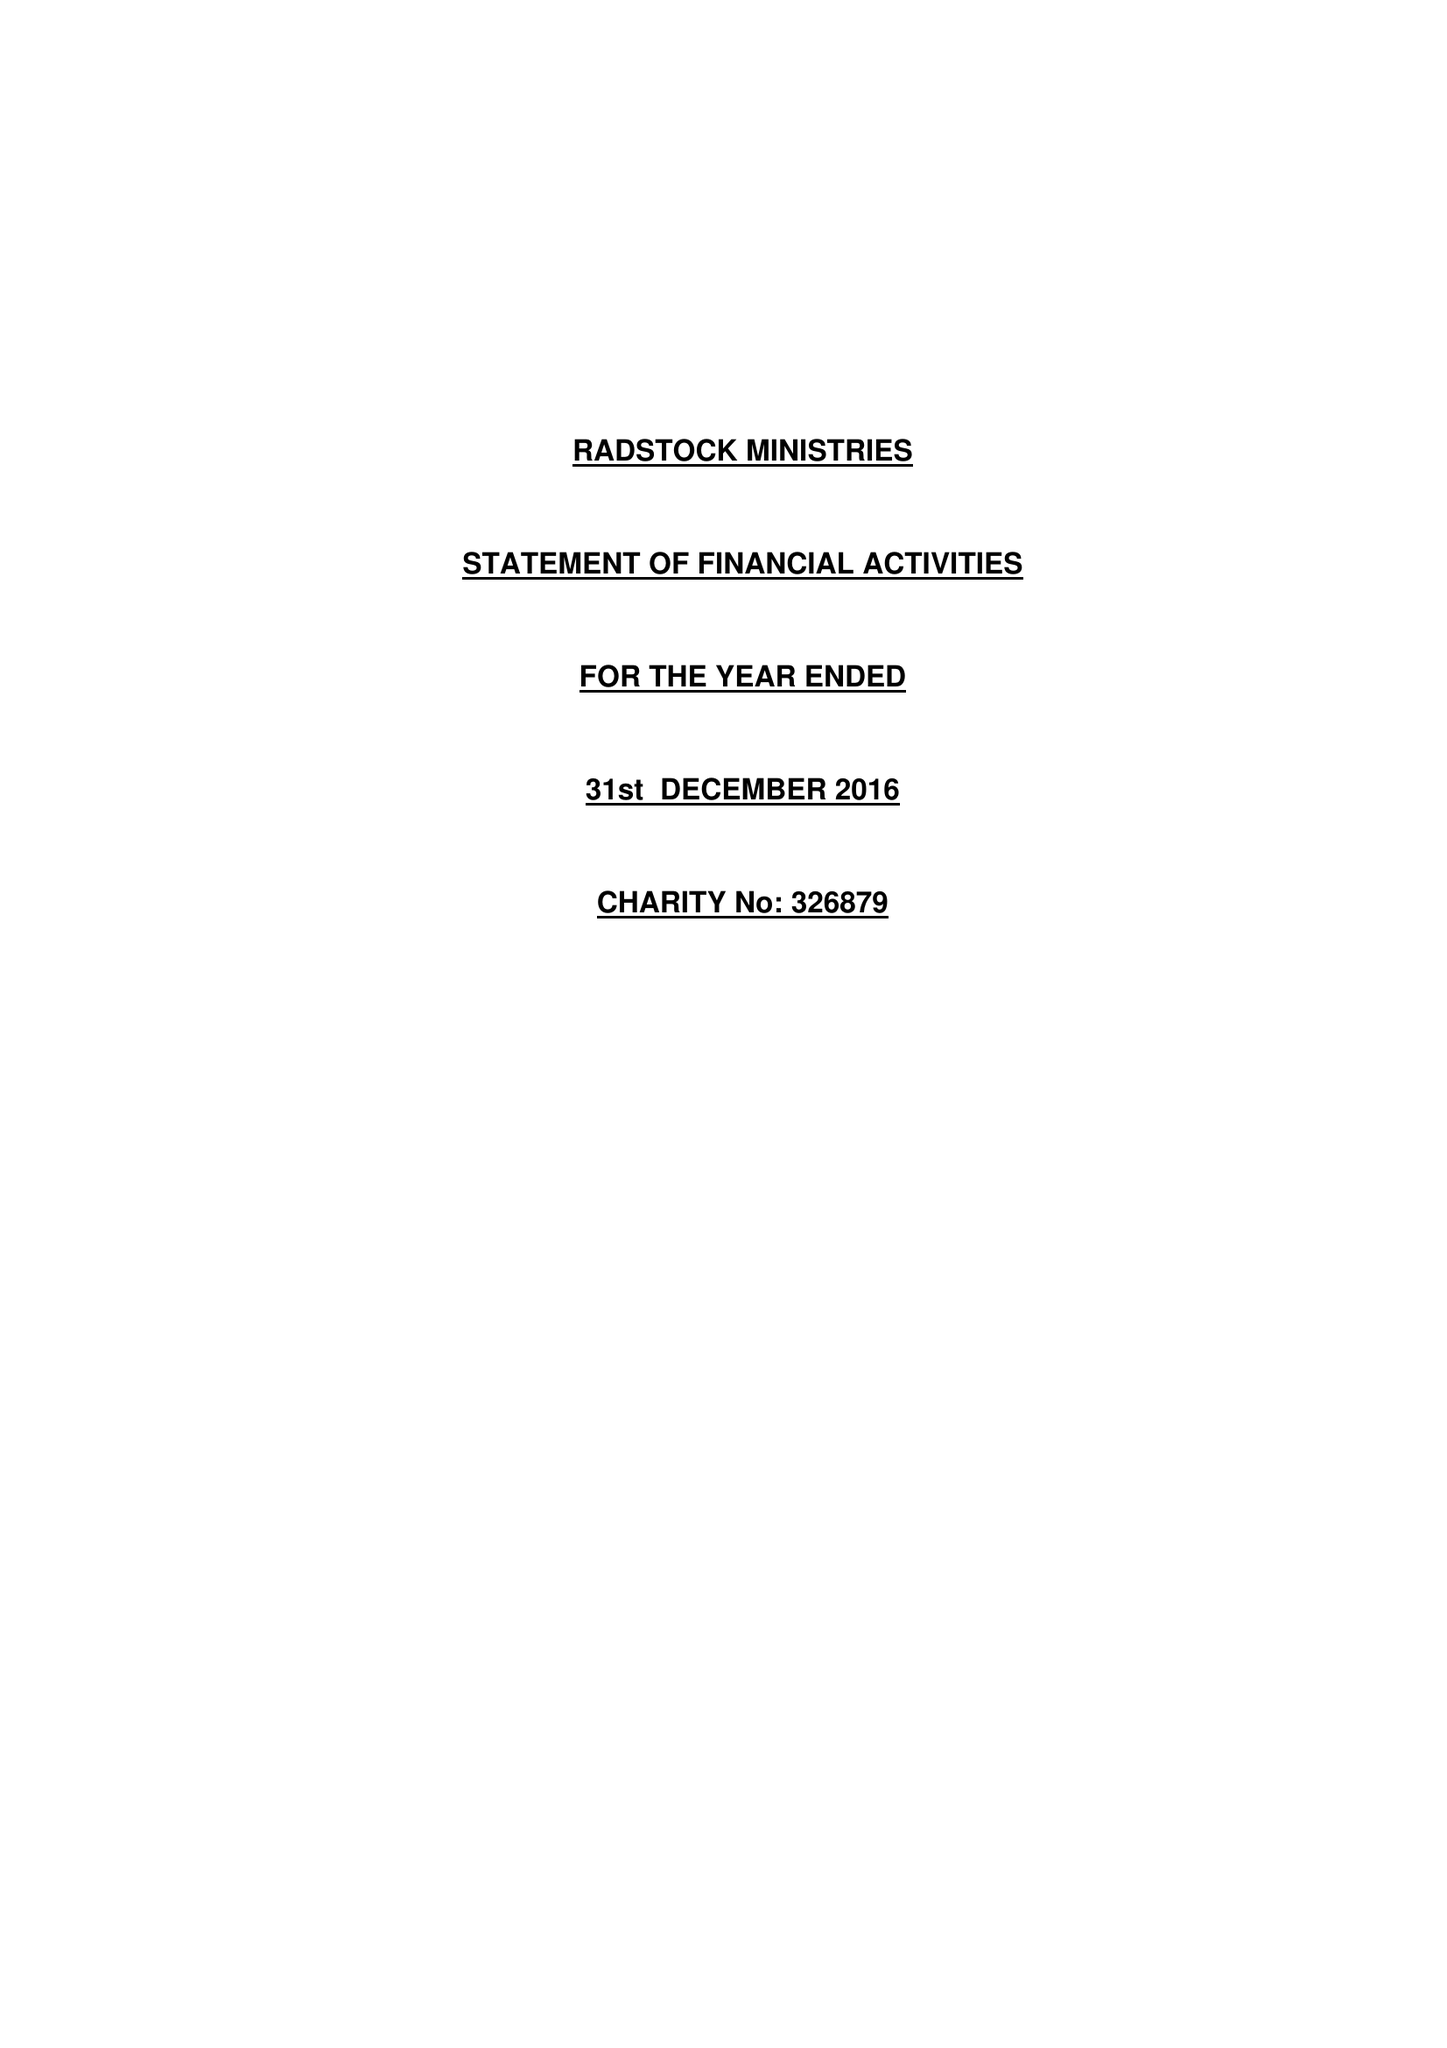What is the value for the address__street_line?
Answer the question using a single word or phrase. ST THOMAS'S ROAD 